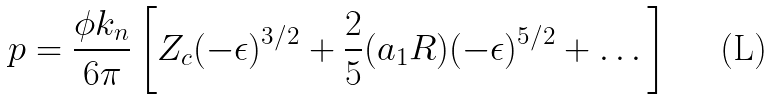Convert formula to latex. <formula><loc_0><loc_0><loc_500><loc_500>p = \frac { \phi k _ { n } } { 6 \pi } \left [ Z _ { c } ( - \epsilon ) ^ { 3 / 2 } + \frac { 2 } { 5 } ( a _ { 1 } R ) ( - \epsilon ) ^ { 5 / 2 } + \dots \right ]</formula> 